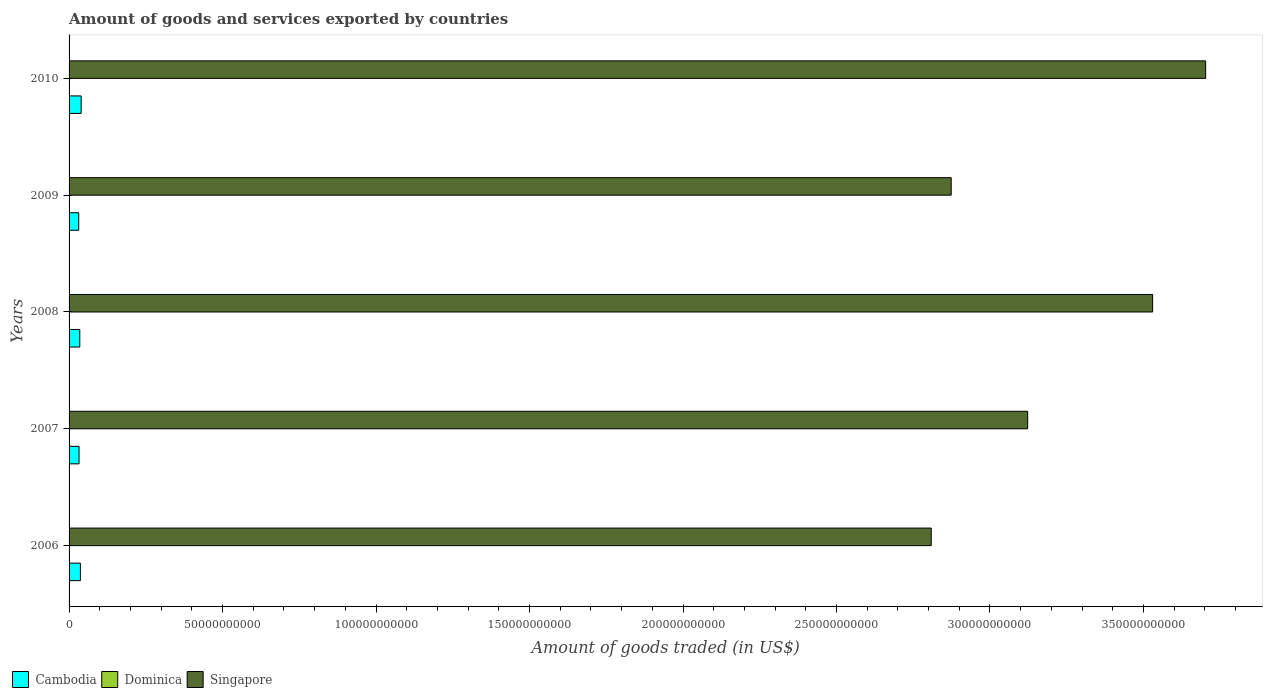How many groups of bars are there?
Provide a short and direct response. 5. Are the number of bars per tick equal to the number of legend labels?
Your answer should be compact. Yes. Are the number of bars on each tick of the Y-axis equal?
Provide a short and direct response. Yes. How many bars are there on the 3rd tick from the top?
Provide a succinct answer. 3. What is the label of the 5th group of bars from the top?
Offer a terse response. 2006. In how many cases, is the number of bars for a given year not equal to the number of legend labels?
Your answer should be very brief. 0. What is the total amount of goods and services exported in Cambodia in 2008?
Provide a short and direct response. 3.49e+09. Across all years, what is the maximum total amount of goods and services exported in Cambodia?
Give a very brief answer. 3.94e+09. Across all years, what is the minimum total amount of goods and services exported in Cambodia?
Provide a short and direct response. 3.15e+09. What is the total total amount of goods and services exported in Cambodia in the graph?
Make the answer very short. 1.75e+1. What is the difference between the total amount of goods and services exported in Dominica in 2007 and that in 2010?
Ensure brevity in your answer.  1.77e+06. What is the difference between the total amount of goods and services exported in Dominica in 2010 and the total amount of goods and services exported in Singapore in 2008?
Give a very brief answer. -3.53e+11. What is the average total amount of goods and services exported in Dominica per year?
Your response must be concise. 4.02e+07. In the year 2010, what is the difference between the total amount of goods and services exported in Cambodia and total amount of goods and services exported in Dominica?
Your response must be concise. 3.90e+09. In how many years, is the total amount of goods and services exported in Singapore greater than 360000000000 US$?
Give a very brief answer. 1. What is the ratio of the total amount of goods and services exported in Cambodia in 2008 to that in 2010?
Offer a terse response. 0.89. What is the difference between the highest and the second highest total amount of goods and services exported in Singapore?
Make the answer very short. 1.73e+1. What is the difference between the highest and the lowest total amount of goods and services exported in Cambodia?
Your response must be concise. 7.91e+08. In how many years, is the total amount of goods and services exported in Singapore greater than the average total amount of goods and services exported in Singapore taken over all years?
Provide a short and direct response. 2. What does the 3rd bar from the top in 2007 represents?
Give a very brief answer. Cambodia. What does the 2nd bar from the bottom in 2006 represents?
Your answer should be compact. Dominica. Are all the bars in the graph horizontal?
Ensure brevity in your answer.  Yes. How many years are there in the graph?
Offer a terse response. 5. Where does the legend appear in the graph?
Your answer should be compact. Bottom left. How many legend labels are there?
Your response must be concise. 3. What is the title of the graph?
Your answer should be compact. Amount of goods and services exported by countries. Does "Cambodia" appear as one of the legend labels in the graph?
Offer a terse response. Yes. What is the label or title of the X-axis?
Make the answer very short. Amount of goods traded (in US$). What is the label or title of the Y-axis?
Offer a very short reply. Years. What is the Amount of goods traded (in US$) in Cambodia in 2006?
Your answer should be compact. 3.69e+09. What is the Amount of goods traded (in US$) of Dominica in 2006?
Offer a terse response. 4.43e+07. What is the Amount of goods traded (in US$) of Singapore in 2006?
Give a very brief answer. 2.81e+11. What is the Amount of goods traded (in US$) in Cambodia in 2007?
Provide a succinct answer. 3.25e+09. What is the Amount of goods traded (in US$) of Dominica in 2007?
Offer a terse response. 3.90e+07. What is the Amount of goods traded (in US$) of Singapore in 2007?
Keep it short and to the point. 3.12e+11. What is the Amount of goods traded (in US$) in Cambodia in 2008?
Keep it short and to the point. 3.49e+09. What is the Amount of goods traded (in US$) in Dominica in 2008?
Give a very brief answer. 4.39e+07. What is the Amount of goods traded (in US$) of Singapore in 2008?
Ensure brevity in your answer.  3.53e+11. What is the Amount of goods traded (in US$) of Cambodia in 2009?
Ensure brevity in your answer.  3.15e+09. What is the Amount of goods traded (in US$) in Dominica in 2009?
Provide a short and direct response. 3.68e+07. What is the Amount of goods traded (in US$) in Singapore in 2009?
Make the answer very short. 2.87e+11. What is the Amount of goods traded (in US$) of Cambodia in 2010?
Offer a terse response. 3.94e+09. What is the Amount of goods traded (in US$) in Dominica in 2010?
Ensure brevity in your answer.  3.72e+07. What is the Amount of goods traded (in US$) of Singapore in 2010?
Ensure brevity in your answer.  3.70e+11. Across all years, what is the maximum Amount of goods traded (in US$) in Cambodia?
Your response must be concise. 3.94e+09. Across all years, what is the maximum Amount of goods traded (in US$) in Dominica?
Give a very brief answer. 4.43e+07. Across all years, what is the maximum Amount of goods traded (in US$) in Singapore?
Provide a short and direct response. 3.70e+11. Across all years, what is the minimum Amount of goods traded (in US$) in Cambodia?
Make the answer very short. 3.15e+09. Across all years, what is the minimum Amount of goods traded (in US$) in Dominica?
Keep it short and to the point. 3.68e+07. Across all years, what is the minimum Amount of goods traded (in US$) of Singapore?
Offer a terse response. 2.81e+11. What is the total Amount of goods traded (in US$) in Cambodia in the graph?
Offer a very short reply. 1.75e+1. What is the total Amount of goods traded (in US$) of Dominica in the graph?
Your answer should be compact. 2.01e+08. What is the total Amount of goods traded (in US$) of Singapore in the graph?
Keep it short and to the point. 1.60e+12. What is the difference between the Amount of goods traded (in US$) in Cambodia in 2006 and that in 2007?
Your answer should be compact. 4.45e+08. What is the difference between the Amount of goods traded (in US$) in Dominica in 2006 and that in 2007?
Ensure brevity in your answer.  5.24e+06. What is the difference between the Amount of goods traded (in US$) in Singapore in 2006 and that in 2007?
Offer a very short reply. -3.14e+1. What is the difference between the Amount of goods traded (in US$) of Cambodia in 2006 and that in 2008?
Keep it short and to the point. 1.99e+08. What is the difference between the Amount of goods traded (in US$) in Dominica in 2006 and that in 2008?
Make the answer very short. 3.75e+05. What is the difference between the Amount of goods traded (in US$) in Singapore in 2006 and that in 2008?
Make the answer very short. -7.21e+1. What is the difference between the Amount of goods traded (in US$) of Cambodia in 2006 and that in 2009?
Ensure brevity in your answer.  5.45e+08. What is the difference between the Amount of goods traded (in US$) in Dominica in 2006 and that in 2009?
Provide a succinct answer. 7.44e+06. What is the difference between the Amount of goods traded (in US$) in Singapore in 2006 and that in 2009?
Your response must be concise. -6.50e+09. What is the difference between the Amount of goods traded (in US$) in Cambodia in 2006 and that in 2010?
Give a very brief answer. -2.46e+08. What is the difference between the Amount of goods traded (in US$) in Dominica in 2006 and that in 2010?
Keep it short and to the point. 7.02e+06. What is the difference between the Amount of goods traded (in US$) of Singapore in 2006 and that in 2010?
Provide a succinct answer. -8.94e+1. What is the difference between the Amount of goods traded (in US$) of Cambodia in 2007 and that in 2008?
Offer a terse response. -2.45e+08. What is the difference between the Amount of goods traded (in US$) of Dominica in 2007 and that in 2008?
Ensure brevity in your answer.  -4.87e+06. What is the difference between the Amount of goods traded (in US$) of Singapore in 2007 and that in 2008?
Your answer should be compact. -4.07e+1. What is the difference between the Amount of goods traded (in US$) in Cambodia in 2007 and that in 2009?
Keep it short and to the point. 9.99e+07. What is the difference between the Amount of goods traded (in US$) of Dominica in 2007 and that in 2009?
Your response must be concise. 2.20e+06. What is the difference between the Amount of goods traded (in US$) in Singapore in 2007 and that in 2009?
Make the answer very short. 2.49e+1. What is the difference between the Amount of goods traded (in US$) of Cambodia in 2007 and that in 2010?
Offer a terse response. -6.91e+08. What is the difference between the Amount of goods traded (in US$) in Dominica in 2007 and that in 2010?
Provide a short and direct response. 1.77e+06. What is the difference between the Amount of goods traded (in US$) in Singapore in 2007 and that in 2010?
Make the answer very short. -5.80e+1. What is the difference between the Amount of goods traded (in US$) in Cambodia in 2008 and that in 2009?
Your answer should be compact. 3.45e+08. What is the difference between the Amount of goods traded (in US$) of Dominica in 2008 and that in 2009?
Give a very brief answer. 7.07e+06. What is the difference between the Amount of goods traded (in US$) in Singapore in 2008 and that in 2009?
Your response must be concise. 6.56e+1. What is the difference between the Amount of goods traded (in US$) of Cambodia in 2008 and that in 2010?
Offer a terse response. -4.45e+08. What is the difference between the Amount of goods traded (in US$) in Dominica in 2008 and that in 2010?
Offer a terse response. 6.64e+06. What is the difference between the Amount of goods traded (in US$) in Singapore in 2008 and that in 2010?
Provide a succinct answer. -1.73e+1. What is the difference between the Amount of goods traded (in US$) of Cambodia in 2009 and that in 2010?
Give a very brief answer. -7.91e+08. What is the difference between the Amount of goods traded (in US$) in Dominica in 2009 and that in 2010?
Offer a very short reply. -4.28e+05. What is the difference between the Amount of goods traded (in US$) in Singapore in 2009 and that in 2010?
Your answer should be very brief. -8.29e+1. What is the difference between the Amount of goods traded (in US$) in Cambodia in 2006 and the Amount of goods traded (in US$) in Dominica in 2007?
Your answer should be compact. 3.65e+09. What is the difference between the Amount of goods traded (in US$) of Cambodia in 2006 and the Amount of goods traded (in US$) of Singapore in 2007?
Your answer should be compact. -3.09e+11. What is the difference between the Amount of goods traded (in US$) in Dominica in 2006 and the Amount of goods traded (in US$) in Singapore in 2007?
Offer a very short reply. -3.12e+11. What is the difference between the Amount of goods traded (in US$) in Cambodia in 2006 and the Amount of goods traded (in US$) in Dominica in 2008?
Make the answer very short. 3.65e+09. What is the difference between the Amount of goods traded (in US$) in Cambodia in 2006 and the Amount of goods traded (in US$) in Singapore in 2008?
Offer a very short reply. -3.49e+11. What is the difference between the Amount of goods traded (in US$) of Dominica in 2006 and the Amount of goods traded (in US$) of Singapore in 2008?
Provide a succinct answer. -3.53e+11. What is the difference between the Amount of goods traded (in US$) in Cambodia in 2006 and the Amount of goods traded (in US$) in Dominica in 2009?
Provide a short and direct response. 3.66e+09. What is the difference between the Amount of goods traded (in US$) of Cambodia in 2006 and the Amount of goods traded (in US$) of Singapore in 2009?
Your response must be concise. -2.84e+11. What is the difference between the Amount of goods traded (in US$) in Dominica in 2006 and the Amount of goods traded (in US$) in Singapore in 2009?
Your response must be concise. -2.87e+11. What is the difference between the Amount of goods traded (in US$) of Cambodia in 2006 and the Amount of goods traded (in US$) of Dominica in 2010?
Offer a very short reply. 3.66e+09. What is the difference between the Amount of goods traded (in US$) of Cambodia in 2006 and the Amount of goods traded (in US$) of Singapore in 2010?
Keep it short and to the point. -3.67e+11. What is the difference between the Amount of goods traded (in US$) in Dominica in 2006 and the Amount of goods traded (in US$) in Singapore in 2010?
Make the answer very short. -3.70e+11. What is the difference between the Amount of goods traded (in US$) in Cambodia in 2007 and the Amount of goods traded (in US$) in Dominica in 2008?
Keep it short and to the point. 3.20e+09. What is the difference between the Amount of goods traded (in US$) in Cambodia in 2007 and the Amount of goods traded (in US$) in Singapore in 2008?
Make the answer very short. -3.50e+11. What is the difference between the Amount of goods traded (in US$) of Dominica in 2007 and the Amount of goods traded (in US$) of Singapore in 2008?
Your response must be concise. -3.53e+11. What is the difference between the Amount of goods traded (in US$) in Cambodia in 2007 and the Amount of goods traded (in US$) in Dominica in 2009?
Ensure brevity in your answer.  3.21e+09. What is the difference between the Amount of goods traded (in US$) of Cambodia in 2007 and the Amount of goods traded (in US$) of Singapore in 2009?
Provide a succinct answer. -2.84e+11. What is the difference between the Amount of goods traded (in US$) of Dominica in 2007 and the Amount of goods traded (in US$) of Singapore in 2009?
Keep it short and to the point. -2.87e+11. What is the difference between the Amount of goods traded (in US$) in Cambodia in 2007 and the Amount of goods traded (in US$) in Dominica in 2010?
Ensure brevity in your answer.  3.21e+09. What is the difference between the Amount of goods traded (in US$) in Cambodia in 2007 and the Amount of goods traded (in US$) in Singapore in 2010?
Provide a succinct answer. -3.67e+11. What is the difference between the Amount of goods traded (in US$) in Dominica in 2007 and the Amount of goods traded (in US$) in Singapore in 2010?
Offer a terse response. -3.70e+11. What is the difference between the Amount of goods traded (in US$) in Cambodia in 2008 and the Amount of goods traded (in US$) in Dominica in 2009?
Offer a very short reply. 3.46e+09. What is the difference between the Amount of goods traded (in US$) of Cambodia in 2008 and the Amount of goods traded (in US$) of Singapore in 2009?
Provide a short and direct response. -2.84e+11. What is the difference between the Amount of goods traded (in US$) of Dominica in 2008 and the Amount of goods traded (in US$) of Singapore in 2009?
Your answer should be very brief. -2.87e+11. What is the difference between the Amount of goods traded (in US$) in Cambodia in 2008 and the Amount of goods traded (in US$) in Dominica in 2010?
Ensure brevity in your answer.  3.46e+09. What is the difference between the Amount of goods traded (in US$) of Cambodia in 2008 and the Amount of goods traded (in US$) of Singapore in 2010?
Make the answer very short. -3.67e+11. What is the difference between the Amount of goods traded (in US$) in Dominica in 2008 and the Amount of goods traded (in US$) in Singapore in 2010?
Keep it short and to the point. -3.70e+11. What is the difference between the Amount of goods traded (in US$) in Cambodia in 2009 and the Amount of goods traded (in US$) in Dominica in 2010?
Offer a terse response. 3.11e+09. What is the difference between the Amount of goods traded (in US$) in Cambodia in 2009 and the Amount of goods traded (in US$) in Singapore in 2010?
Provide a short and direct response. -3.67e+11. What is the difference between the Amount of goods traded (in US$) in Dominica in 2009 and the Amount of goods traded (in US$) in Singapore in 2010?
Provide a succinct answer. -3.70e+11. What is the average Amount of goods traded (in US$) of Cambodia per year?
Make the answer very short. 3.50e+09. What is the average Amount of goods traded (in US$) of Dominica per year?
Your answer should be very brief. 4.02e+07. What is the average Amount of goods traded (in US$) in Singapore per year?
Give a very brief answer. 3.21e+11. In the year 2006, what is the difference between the Amount of goods traded (in US$) in Cambodia and Amount of goods traded (in US$) in Dominica?
Provide a short and direct response. 3.65e+09. In the year 2006, what is the difference between the Amount of goods traded (in US$) of Cambodia and Amount of goods traded (in US$) of Singapore?
Offer a very short reply. -2.77e+11. In the year 2006, what is the difference between the Amount of goods traded (in US$) in Dominica and Amount of goods traded (in US$) in Singapore?
Offer a very short reply. -2.81e+11. In the year 2007, what is the difference between the Amount of goods traded (in US$) of Cambodia and Amount of goods traded (in US$) of Dominica?
Provide a succinct answer. 3.21e+09. In the year 2007, what is the difference between the Amount of goods traded (in US$) in Cambodia and Amount of goods traded (in US$) in Singapore?
Ensure brevity in your answer.  -3.09e+11. In the year 2007, what is the difference between the Amount of goods traded (in US$) of Dominica and Amount of goods traded (in US$) of Singapore?
Offer a very short reply. -3.12e+11. In the year 2008, what is the difference between the Amount of goods traded (in US$) in Cambodia and Amount of goods traded (in US$) in Dominica?
Your answer should be very brief. 3.45e+09. In the year 2008, what is the difference between the Amount of goods traded (in US$) of Cambodia and Amount of goods traded (in US$) of Singapore?
Your response must be concise. -3.49e+11. In the year 2008, what is the difference between the Amount of goods traded (in US$) in Dominica and Amount of goods traded (in US$) in Singapore?
Your response must be concise. -3.53e+11. In the year 2009, what is the difference between the Amount of goods traded (in US$) of Cambodia and Amount of goods traded (in US$) of Dominica?
Provide a short and direct response. 3.11e+09. In the year 2009, what is the difference between the Amount of goods traded (in US$) of Cambodia and Amount of goods traded (in US$) of Singapore?
Your answer should be very brief. -2.84e+11. In the year 2009, what is the difference between the Amount of goods traded (in US$) in Dominica and Amount of goods traded (in US$) in Singapore?
Provide a succinct answer. -2.87e+11. In the year 2010, what is the difference between the Amount of goods traded (in US$) of Cambodia and Amount of goods traded (in US$) of Dominica?
Offer a very short reply. 3.90e+09. In the year 2010, what is the difference between the Amount of goods traded (in US$) of Cambodia and Amount of goods traded (in US$) of Singapore?
Offer a terse response. -3.66e+11. In the year 2010, what is the difference between the Amount of goods traded (in US$) in Dominica and Amount of goods traded (in US$) in Singapore?
Make the answer very short. -3.70e+11. What is the ratio of the Amount of goods traded (in US$) in Cambodia in 2006 to that in 2007?
Your response must be concise. 1.14. What is the ratio of the Amount of goods traded (in US$) of Dominica in 2006 to that in 2007?
Make the answer very short. 1.13. What is the ratio of the Amount of goods traded (in US$) in Singapore in 2006 to that in 2007?
Give a very brief answer. 0.9. What is the ratio of the Amount of goods traded (in US$) of Cambodia in 2006 to that in 2008?
Give a very brief answer. 1.06. What is the ratio of the Amount of goods traded (in US$) of Dominica in 2006 to that in 2008?
Give a very brief answer. 1.01. What is the ratio of the Amount of goods traded (in US$) in Singapore in 2006 to that in 2008?
Offer a terse response. 0.8. What is the ratio of the Amount of goods traded (in US$) in Cambodia in 2006 to that in 2009?
Provide a short and direct response. 1.17. What is the ratio of the Amount of goods traded (in US$) of Dominica in 2006 to that in 2009?
Ensure brevity in your answer.  1.2. What is the ratio of the Amount of goods traded (in US$) in Singapore in 2006 to that in 2009?
Give a very brief answer. 0.98. What is the ratio of the Amount of goods traded (in US$) in Cambodia in 2006 to that in 2010?
Offer a terse response. 0.94. What is the ratio of the Amount of goods traded (in US$) in Dominica in 2006 to that in 2010?
Keep it short and to the point. 1.19. What is the ratio of the Amount of goods traded (in US$) of Singapore in 2006 to that in 2010?
Provide a succinct answer. 0.76. What is the ratio of the Amount of goods traded (in US$) of Cambodia in 2007 to that in 2008?
Make the answer very short. 0.93. What is the ratio of the Amount of goods traded (in US$) of Dominica in 2007 to that in 2008?
Make the answer very short. 0.89. What is the ratio of the Amount of goods traded (in US$) in Singapore in 2007 to that in 2008?
Ensure brevity in your answer.  0.88. What is the ratio of the Amount of goods traded (in US$) of Cambodia in 2007 to that in 2009?
Give a very brief answer. 1.03. What is the ratio of the Amount of goods traded (in US$) of Dominica in 2007 to that in 2009?
Your response must be concise. 1.06. What is the ratio of the Amount of goods traded (in US$) in Singapore in 2007 to that in 2009?
Give a very brief answer. 1.09. What is the ratio of the Amount of goods traded (in US$) of Cambodia in 2007 to that in 2010?
Ensure brevity in your answer.  0.82. What is the ratio of the Amount of goods traded (in US$) of Dominica in 2007 to that in 2010?
Give a very brief answer. 1.05. What is the ratio of the Amount of goods traded (in US$) in Singapore in 2007 to that in 2010?
Your answer should be compact. 0.84. What is the ratio of the Amount of goods traded (in US$) in Cambodia in 2008 to that in 2009?
Keep it short and to the point. 1.11. What is the ratio of the Amount of goods traded (in US$) in Dominica in 2008 to that in 2009?
Offer a terse response. 1.19. What is the ratio of the Amount of goods traded (in US$) of Singapore in 2008 to that in 2009?
Provide a short and direct response. 1.23. What is the ratio of the Amount of goods traded (in US$) of Cambodia in 2008 to that in 2010?
Your response must be concise. 0.89. What is the ratio of the Amount of goods traded (in US$) in Dominica in 2008 to that in 2010?
Give a very brief answer. 1.18. What is the ratio of the Amount of goods traded (in US$) in Singapore in 2008 to that in 2010?
Your answer should be compact. 0.95. What is the ratio of the Amount of goods traded (in US$) of Cambodia in 2009 to that in 2010?
Your response must be concise. 0.8. What is the ratio of the Amount of goods traded (in US$) in Dominica in 2009 to that in 2010?
Provide a succinct answer. 0.99. What is the ratio of the Amount of goods traded (in US$) in Singapore in 2009 to that in 2010?
Provide a succinct answer. 0.78. What is the difference between the highest and the second highest Amount of goods traded (in US$) in Cambodia?
Keep it short and to the point. 2.46e+08. What is the difference between the highest and the second highest Amount of goods traded (in US$) of Dominica?
Offer a very short reply. 3.75e+05. What is the difference between the highest and the second highest Amount of goods traded (in US$) in Singapore?
Provide a succinct answer. 1.73e+1. What is the difference between the highest and the lowest Amount of goods traded (in US$) of Cambodia?
Provide a succinct answer. 7.91e+08. What is the difference between the highest and the lowest Amount of goods traded (in US$) of Dominica?
Provide a succinct answer. 7.44e+06. What is the difference between the highest and the lowest Amount of goods traded (in US$) in Singapore?
Keep it short and to the point. 8.94e+1. 